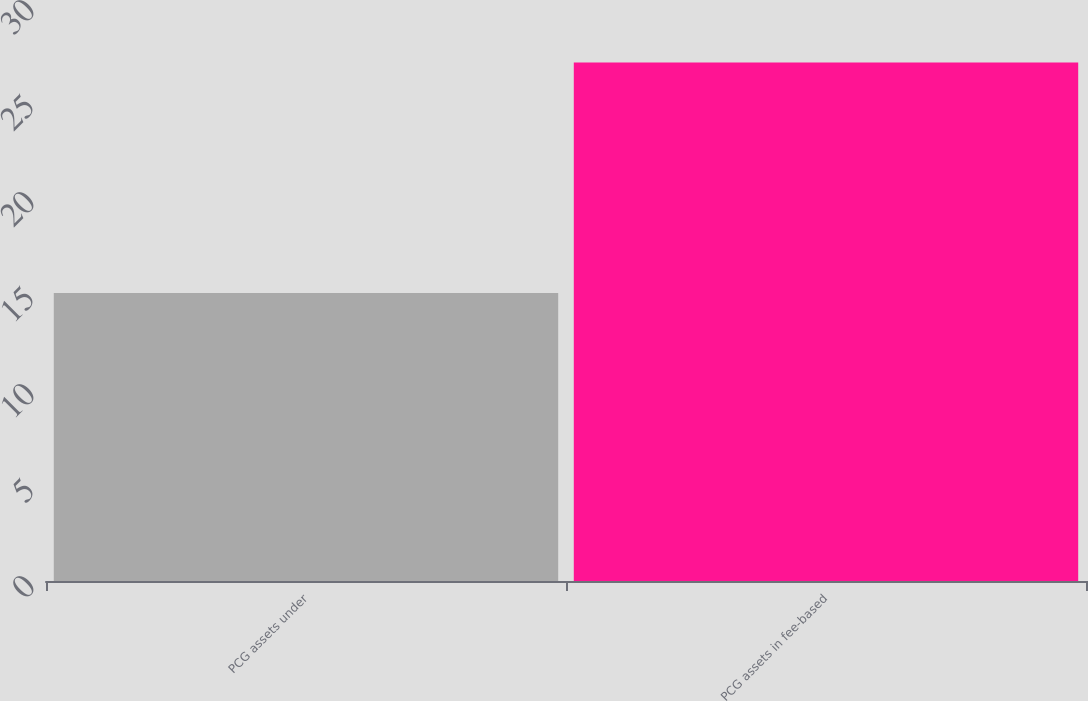<chart> <loc_0><loc_0><loc_500><loc_500><bar_chart><fcel>PCG assets under<fcel>PCG assets in fee-based<nl><fcel>15<fcel>27<nl></chart> 